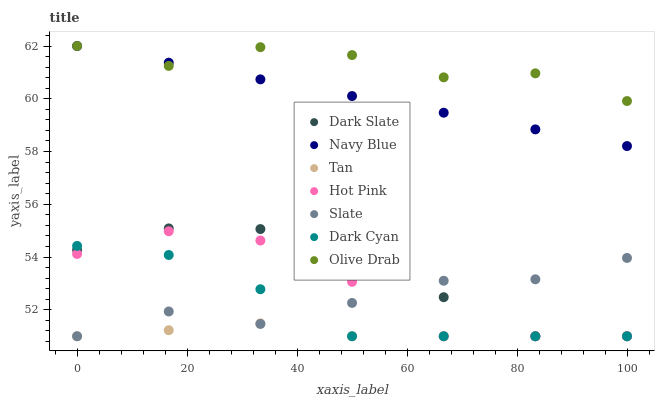Does Tan have the minimum area under the curve?
Answer yes or no. Yes. Does Olive Drab have the maximum area under the curve?
Answer yes or no. Yes. Does Slate have the minimum area under the curve?
Answer yes or no. No. Does Slate have the maximum area under the curve?
Answer yes or no. No. Is Navy Blue the smoothest?
Answer yes or no. Yes. Is Olive Drab the roughest?
Answer yes or no. Yes. Is Slate the smoothest?
Answer yes or no. No. Is Slate the roughest?
Answer yes or no. No. Does Slate have the lowest value?
Answer yes or no. Yes. Does Olive Drab have the lowest value?
Answer yes or no. No. Does Olive Drab have the highest value?
Answer yes or no. Yes. Does Slate have the highest value?
Answer yes or no. No. Is Hot Pink less than Olive Drab?
Answer yes or no. Yes. Is Olive Drab greater than Dark Slate?
Answer yes or no. Yes. Does Tan intersect Slate?
Answer yes or no. Yes. Is Tan less than Slate?
Answer yes or no. No. Is Tan greater than Slate?
Answer yes or no. No. Does Hot Pink intersect Olive Drab?
Answer yes or no. No. 